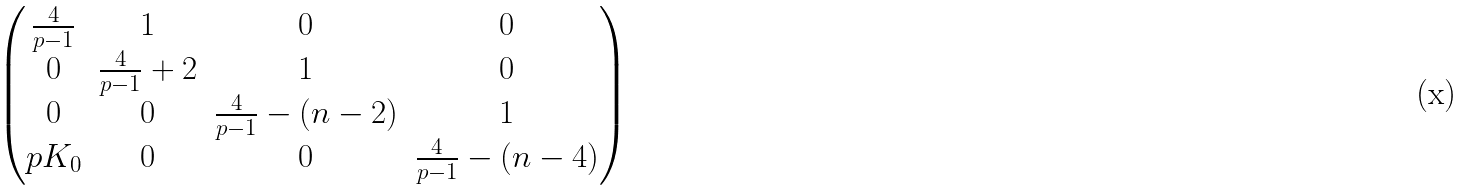<formula> <loc_0><loc_0><loc_500><loc_500>\begin{pmatrix} \frac { 4 } { p - 1 } & 1 & 0 & 0 \\ 0 & \frac { 4 } { p - 1 } + 2 & 1 & 0 \\ 0 & 0 & \frac { 4 } { p - 1 } - ( n - 2 ) & 1 \\ p K _ { 0 } & 0 & 0 & \frac { 4 } { p - 1 } - ( n - 4 ) \\ \end{pmatrix}</formula> 